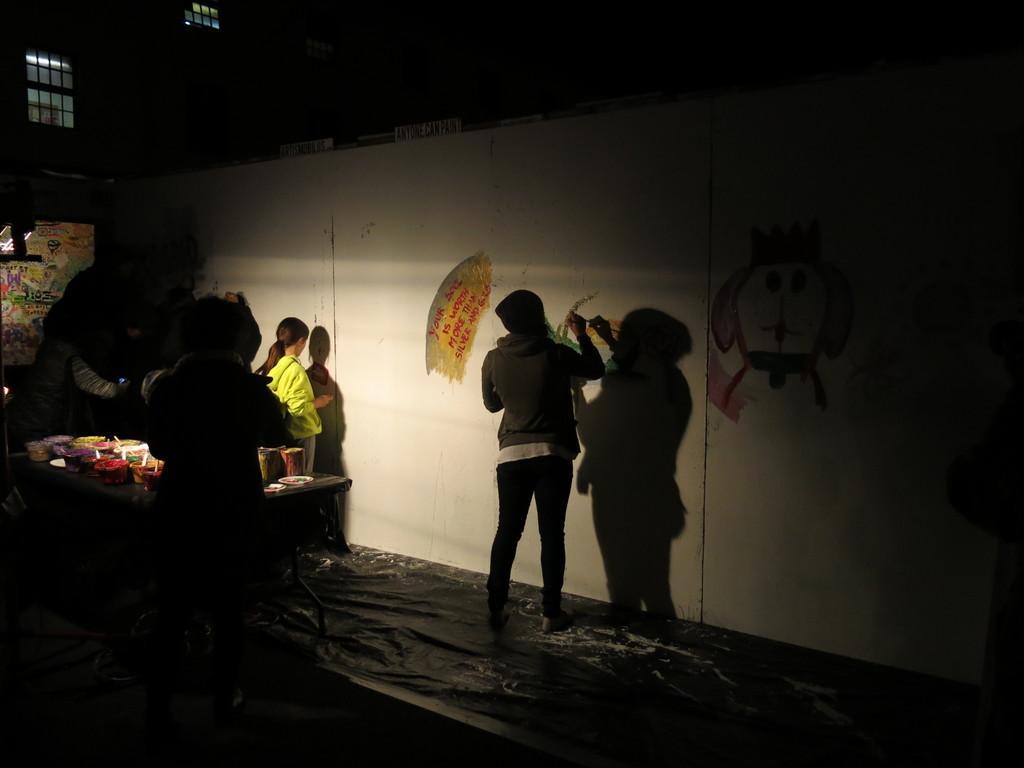In one or two sentences, can you explain what this image depicts? In this picture I can see people, wall, windows, table and objects. Few objects are on the table. One person is painting on the wall.   